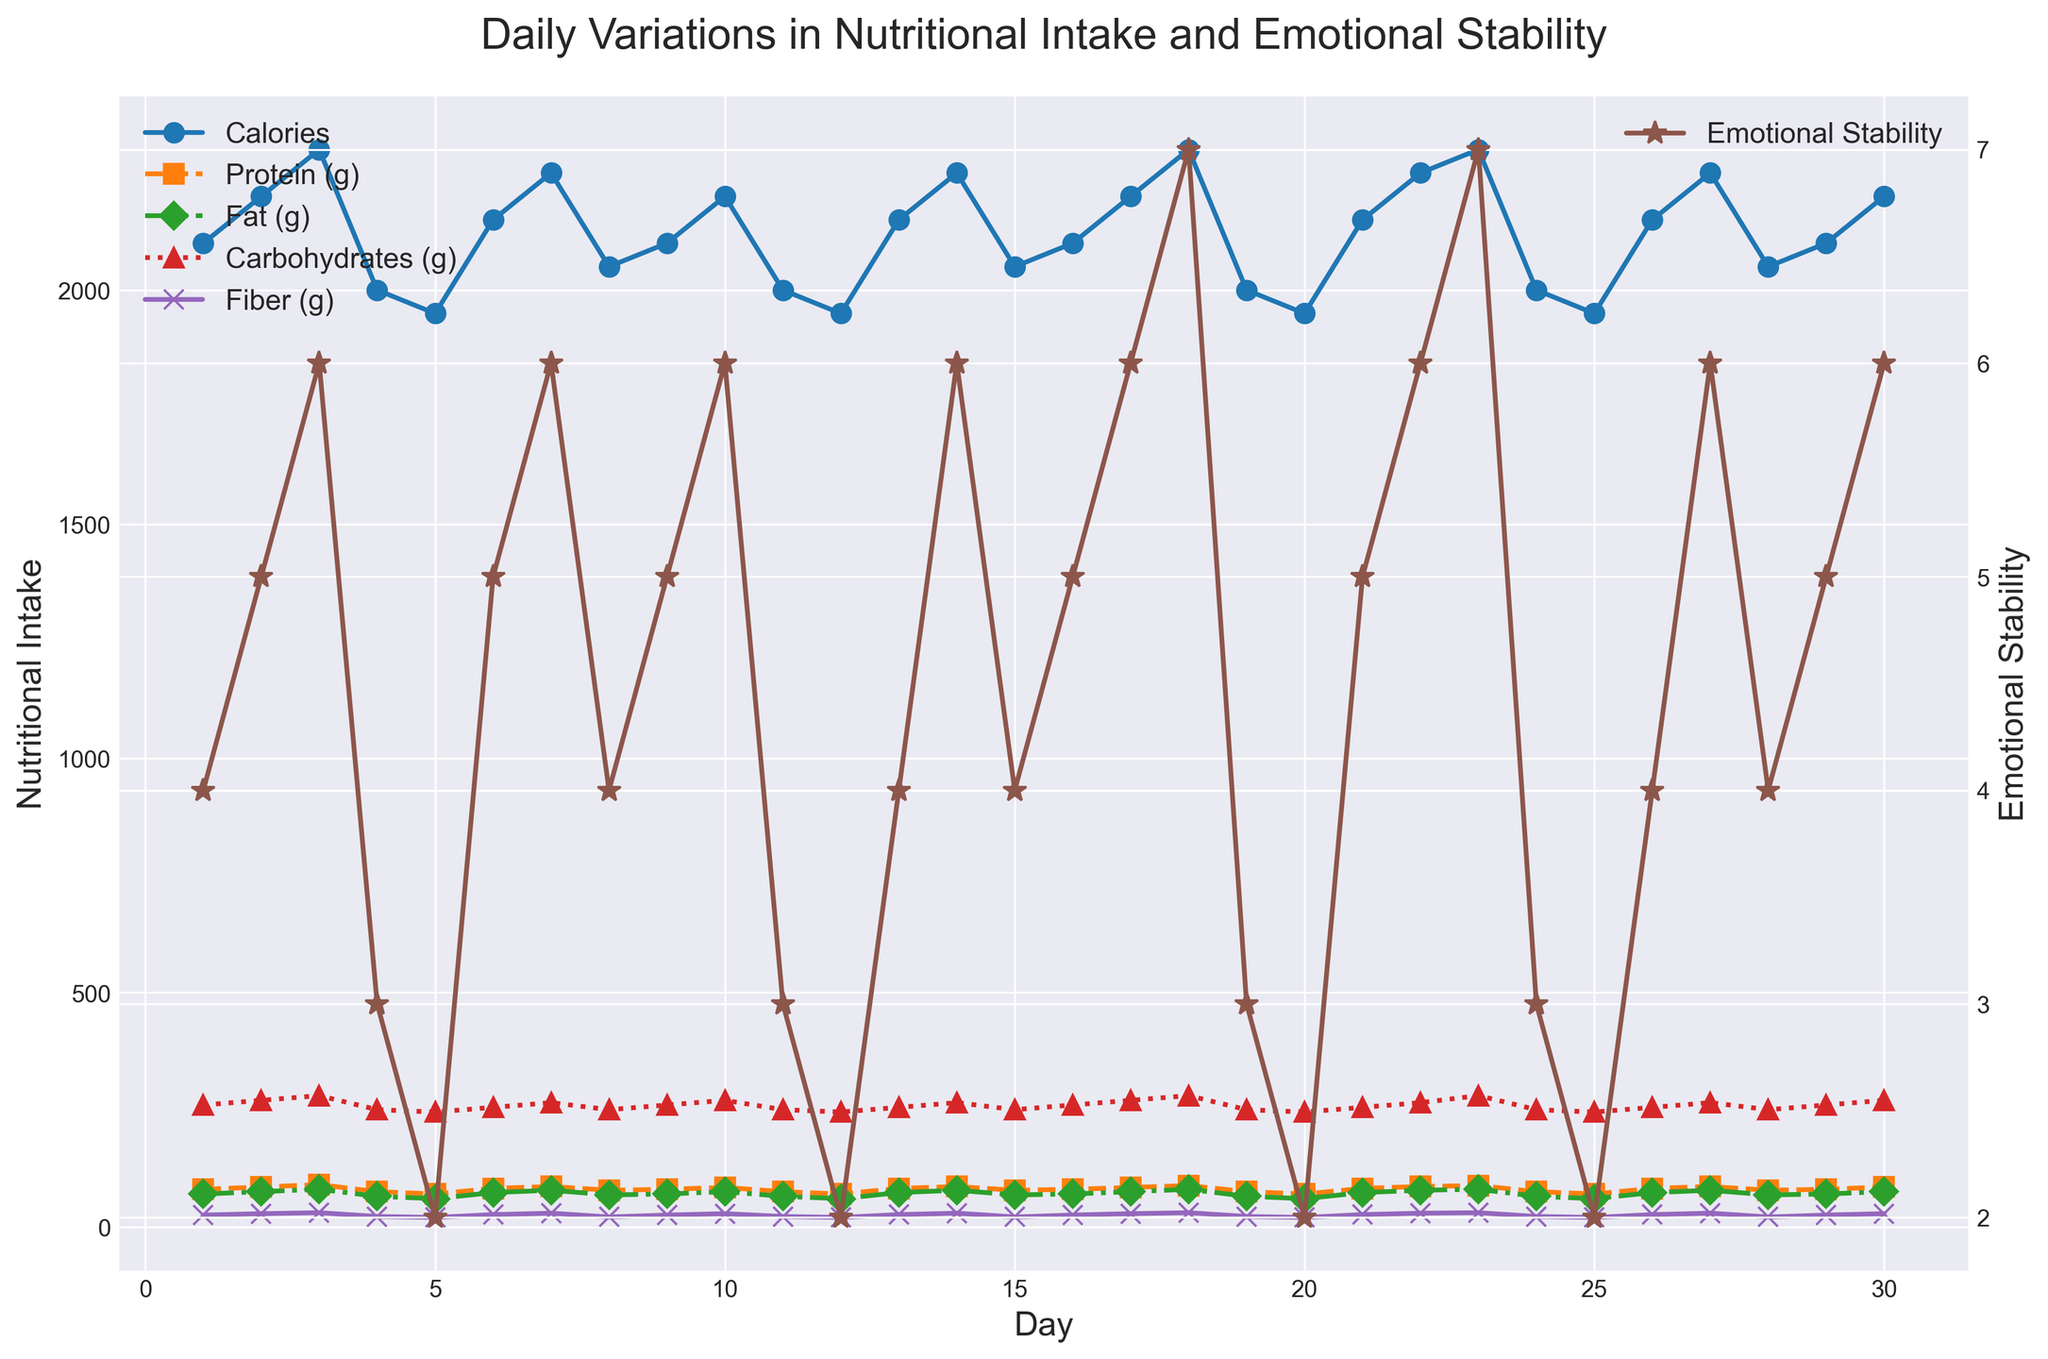What is the highest value of Emotional Stability observed over the month? Look at the right y-axis for Emotional Stability and identify the highest peak. It's on Day 23 with a value of 7.
Answer: 7 On which day does Fiber intake reach its highest value? Examine the purple "x" markers representing Fiber. They peak on Day 3 at 30 grams and match on Days 18 and 23.
Answer: Day 3, 18, 23 Compare the Calories intake and Emotional Stability on Day 5, which is higher? On Day 5, Calories intake is 1950. Check the brown line for Emotional Stability, which is 2. Therefore, Calories intake is higher.
Answer: Calories intake How many days have both Calories intake greater than 2100 and Emotional Stability greater than or equal to 6? Identify days where Calories are >2100 and Emotional Stability >=6. They are Days 3, 18, 23, and 27, giving 4 days in total.
Answer: 4 What is the average Protein intake from Day 11 to Day 20? Sum the Protein intake values from Day 11 (75g) to Day 20 (70g) and divide by the number of days (10). Total is 75 + 70 + 82 + 86 + 78 + 80 + 84 + 88 + 75 + 70 = 788. Average = 788/10 = 78.8 grams.
Answer: 78.8 grams Which day shows the largest drop in Calories intake from the previous day? Check daily changes in Calories intake. The largest drop is from Day 3 (2300) to Day 4 (2000), a drop of 300 calories.
Answer: Day 4 Is there any day where Fat intake is greater than both Protein and Fiber intakes? Compare Fat, Protein, and Fiber intakes across days. Day 1 shows Fat (70) greater than Protein (80) and Fiber (25).
Answer: None What color represents the Carbohydrates intake on the plot? Identify the marker for Carbohydrates intake, which is colored red.
Answer: Red On which day is Emotional Stability equal to 6 for the first time? Trace the Emotional Stability markers on the brown line. The first occurrence of 6 is on Day 3.
Answer: Day 3 Compare days when Calories intake is 2100. How does Emotional Stability vary on these days? Days with 2100 Calories are Day 1, 9, 16 and 29. Emotional Stability on these days: Day 1 - 4, Day 9 - 5, Day 16 - 5, and Day 29 - 5.
Answer: Varies between 4 and 5 